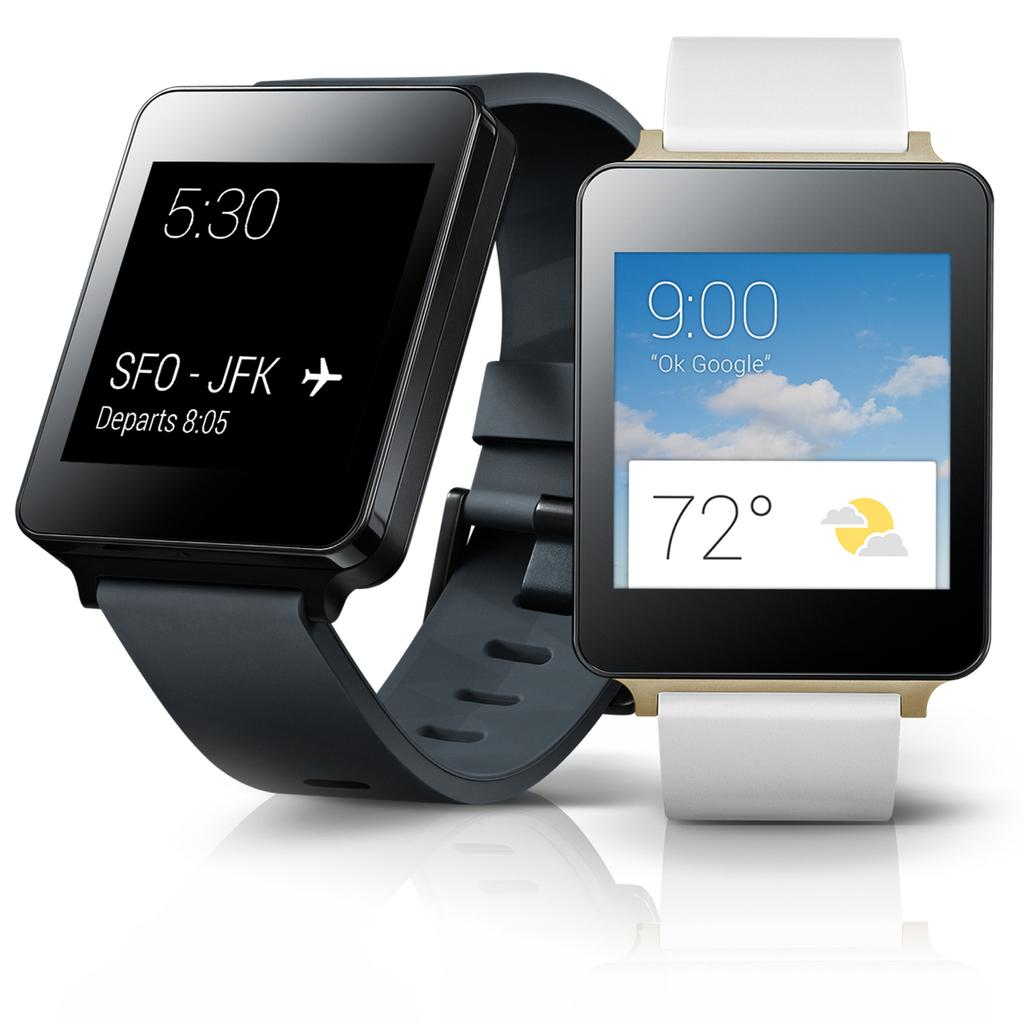<image>
Relay a brief, clear account of the picture shown. A black smart watch is displaying the departure schedule of a flight from SFO to JFK. 